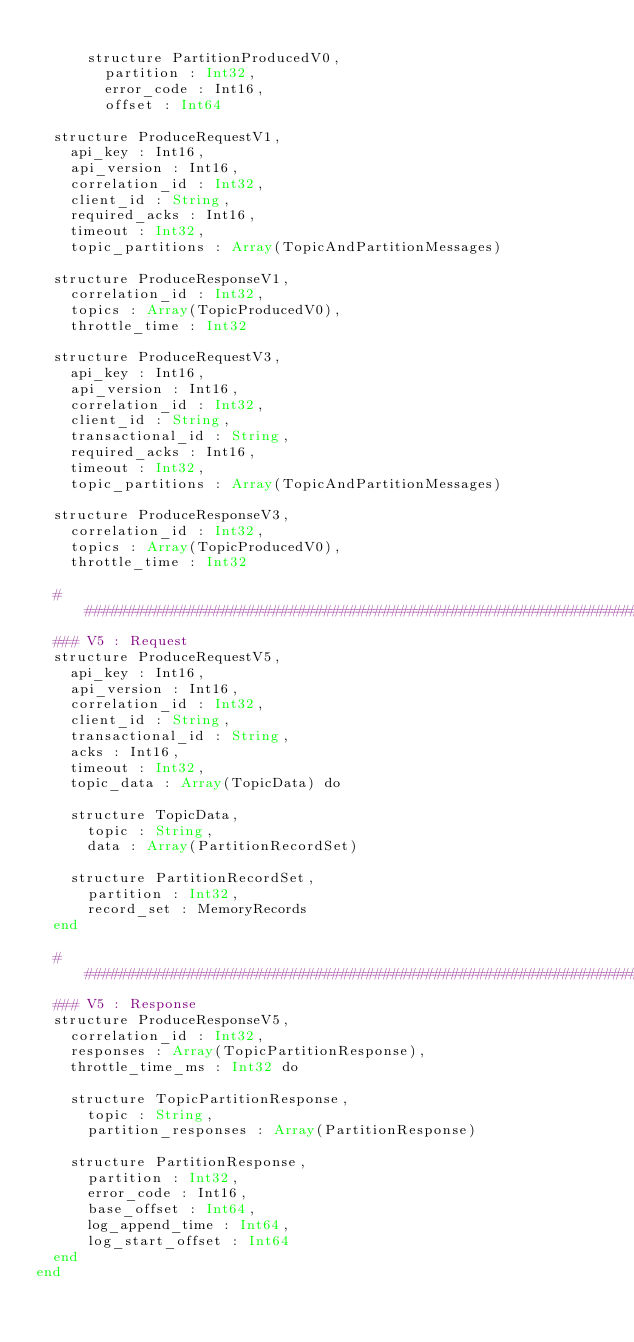Convert code to text. <code><loc_0><loc_0><loc_500><loc_500><_Crystal_>
      structure PartitionProducedV0,
        partition : Int32,
        error_code : Int16,
        offset : Int64

  structure ProduceRequestV1,
    api_key : Int16,
    api_version : Int16,
    correlation_id : Int32,
    client_id : String,
    required_acks : Int16,
    timeout : Int32,
    topic_partitions : Array(TopicAndPartitionMessages)

  structure ProduceResponseV1,
    correlation_id : Int32,
    topics : Array(TopicProducedV0),
    throttle_time : Int32
  
  structure ProduceRequestV3,
    api_key : Int16,
    api_version : Int16,
    correlation_id : Int32,
    client_id : String,
    transactional_id : String,
    required_acks : Int16,
    timeout : Int32,
    topic_partitions : Array(TopicAndPartitionMessages)

  structure ProduceResponseV3,
    correlation_id : Int32,
    topics : Array(TopicProducedV0),
    throttle_time : Int32

  ######################################################################
  ### V5 : Request
  structure ProduceRequestV5,
    api_key : Int16,
    api_version : Int16,
    correlation_id : Int32,
    client_id : String,
    transactional_id : String,
    acks : Int16,
    timeout : Int32,
    topic_data : Array(TopicData) do

    structure TopicData,
      topic : String,
      data : Array(PartitionRecordSet)

    structure PartitionRecordSet,
      partition : Int32,
      record_set : MemoryRecords
  end
  
  ######################################################################
  ### V5 : Response
  structure ProduceResponseV5,
    correlation_id : Int32,
    responses : Array(TopicPartitionResponse),
    throttle_time_ms : Int32 do

    structure TopicPartitionResponse,
      topic : String,
      partition_responses : Array(PartitionResponse)

    structure PartitionResponse,
      partition : Int32,
      error_code : Int16,
      base_offset : Int64,
      log_append_time : Int64,
      log_start_offset : Int64
  end  
end
</code> 